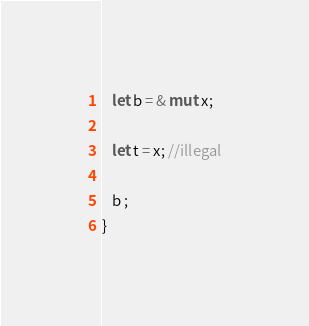<code> <loc_0><loc_0><loc_500><loc_500><_Rust_>   let b = & mut x;

   let t = x; //illegal
   
   b ;
}</code> 